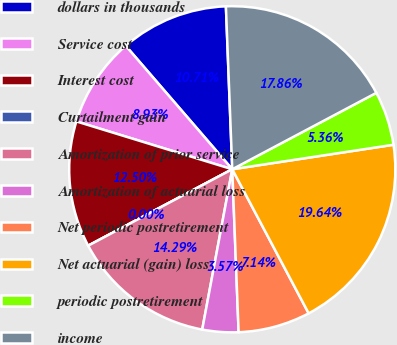Convert chart to OTSL. <chart><loc_0><loc_0><loc_500><loc_500><pie_chart><fcel>dollars in thousands<fcel>Service cost<fcel>Interest cost<fcel>Curtailment gain<fcel>Amortization of prior service<fcel>Amortization of actuarial loss<fcel>Net periodic postretirement<fcel>Net actuarial (gain) loss<fcel>periodic postretirement<fcel>income<nl><fcel>10.71%<fcel>8.93%<fcel>12.5%<fcel>0.0%<fcel>14.29%<fcel>3.57%<fcel>7.14%<fcel>19.64%<fcel>5.36%<fcel>17.86%<nl></chart> 